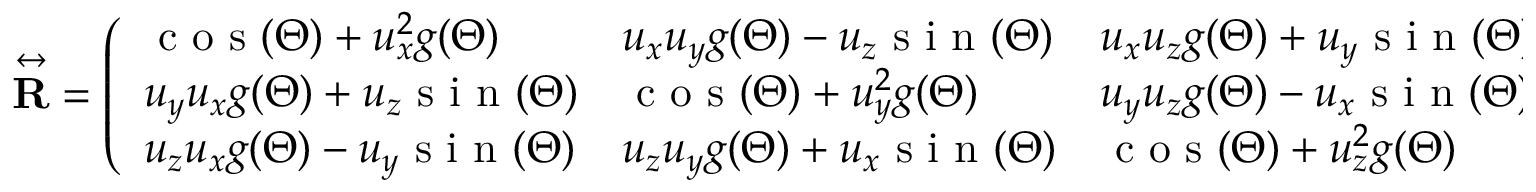<formula> <loc_0><loc_0><loc_500><loc_500>\overset { \leftrightarrow } R } = \left ( \begin{array} { l l l } { c o s ( \Theta ) + u _ { x } ^ { 2 } g ( \Theta ) } & { u _ { x } u _ { y } g ( \Theta ) - u _ { z } s i n ( \Theta ) } & { u _ { x } u _ { z } g ( \Theta ) + u _ { y } s i n ( \Theta ) } \\ { u _ { y } u _ { x } g ( \Theta ) + u _ { z } s i n ( \Theta ) } & { c o s ( \Theta ) + u _ { y } ^ { 2 } g ( \Theta ) } & { u _ { y } u _ { z } g ( \Theta ) - u _ { x } s i n ( \Theta ) } \\ { u _ { z } u _ { x } g ( \Theta ) - u _ { y } s i n ( \Theta ) } & { u _ { z } u _ { y } g ( \Theta ) + u _ { x } s i n ( \Theta ) } & { c o s ( \Theta ) + u _ { z } ^ { 2 } g ( \Theta ) } \end{array} \right )</formula> 